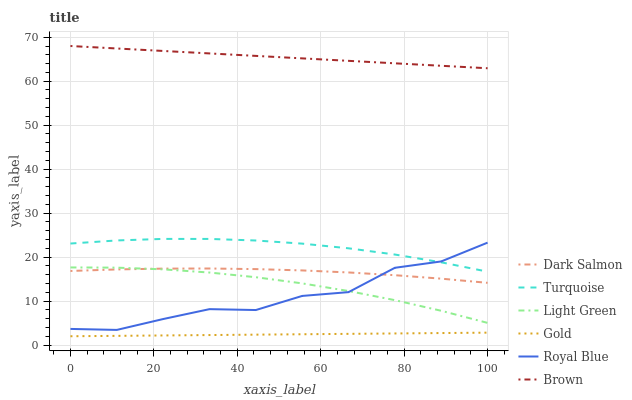Does Turquoise have the minimum area under the curve?
Answer yes or no. No. Does Turquoise have the maximum area under the curve?
Answer yes or no. No. Is Turquoise the smoothest?
Answer yes or no. No. Is Turquoise the roughest?
Answer yes or no. No. Does Turquoise have the lowest value?
Answer yes or no. No. Does Turquoise have the highest value?
Answer yes or no. No. Is Royal Blue less than Brown?
Answer yes or no. Yes. Is Turquoise greater than Light Green?
Answer yes or no. Yes. Does Royal Blue intersect Brown?
Answer yes or no. No. 